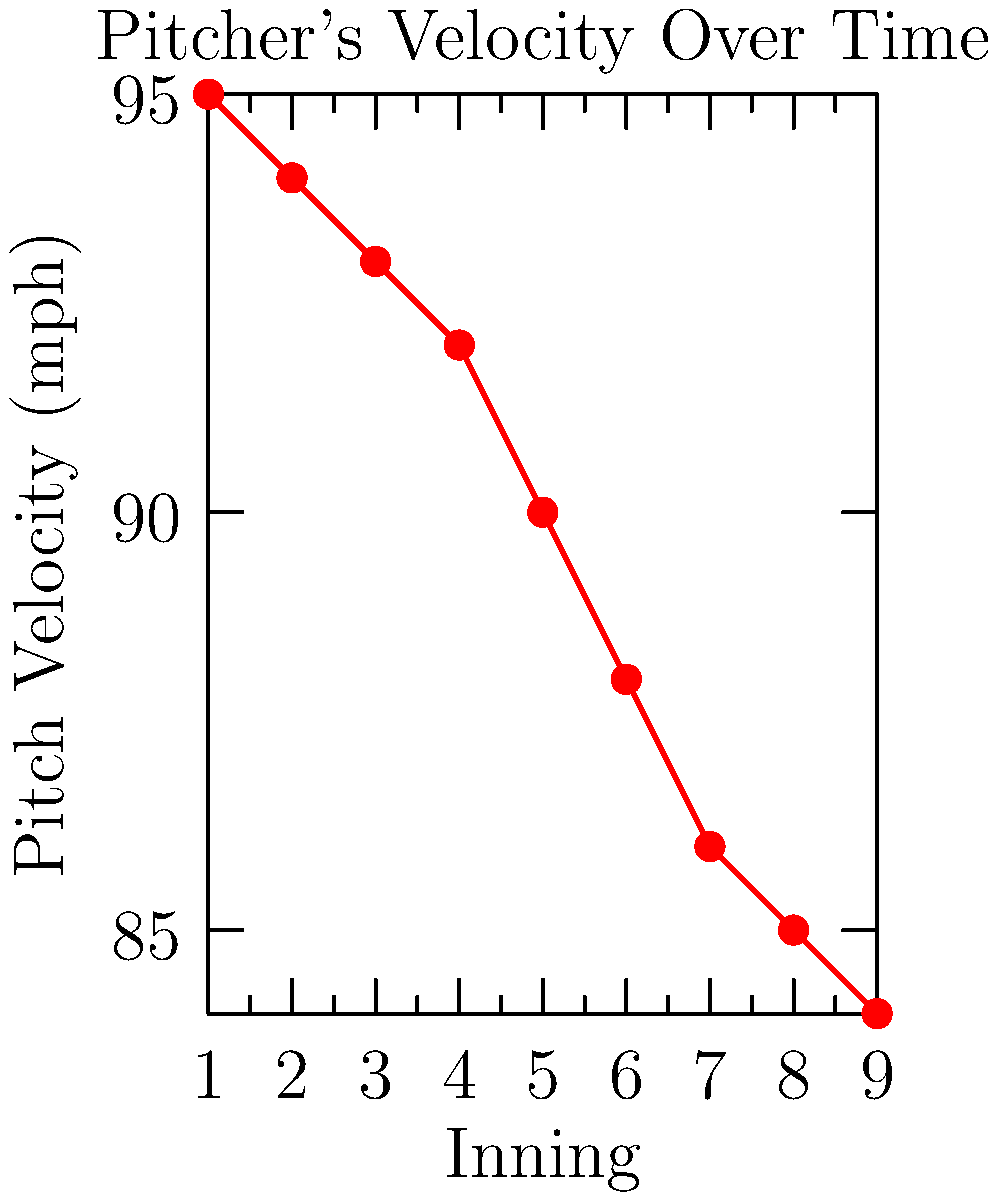Analyze the time-series plot of a pitcher's velocity throughout a game. What does the trend suggest about the pitcher's fatigue, and at which point would you consider removing the pitcher from the game? To analyze the pitcher's fatigue and determine when to remove them from the game, let's examine the plot step-by-step:

1. The x-axis represents innings pitched, while the y-axis shows pitch velocity in mph.

2. We observe a clear downward trend in pitch velocity as the game progresses:
   - Starting velocity: 95 mph (1st inning)
   - Ending velocity: 84 mph (9th inning)

3. Calculate the total velocity drop:
   $\text{Velocity drop} = 95 \text{ mph} - 84 \text{ mph} = 11 \text{ mph}$

4. Determine the average velocity drop per inning:
   $\text{Average drop per inning} = \frac{11 \text{ mph}}{9 \text{ innings}} \approx 1.22 \text{ mph/inning}$

5. Look for significant drops or changes in the trend:
   - The slope appears steeper between innings 4-6
   - After the 6th inning, velocity drops below 90 mph

6. Consider common baseball strategy:
   - Pitchers often throw 100-110 pitches per game
   - Many teams prefer to remove starting pitchers after 6-7 innings

7. Factoring in fatigue and performance:
   - The 6th inning marks a notable decline in velocity
   - Velocity drops below 90 mph after the 6th inning

Given these observations, it would be advisable to remove the pitcher after the 6th inning. At this point, there's a clear indication of fatigue, and the risk of decreased performance or potential injury increases.
Answer: Remove the pitcher after the 6th inning due to significant velocity drop indicating fatigue. 